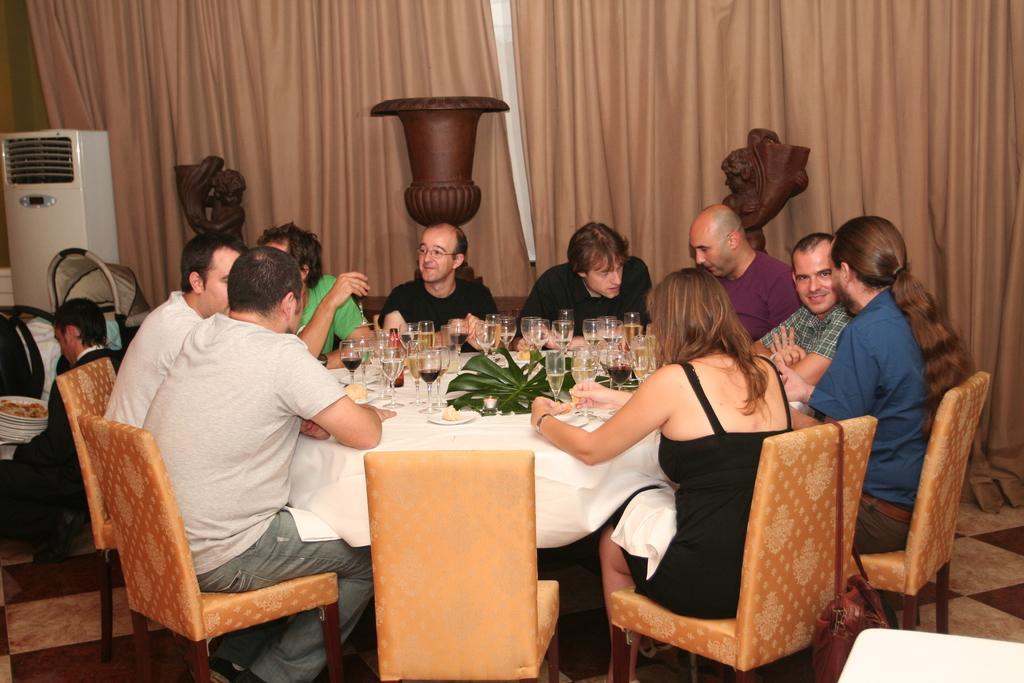In one or two sentences, can you explain what this image depicts? In this image we can see few people are sitting on the chairs around the table. There are many glasses on the table. In the background of the image we can see curtains and air conditioner. 